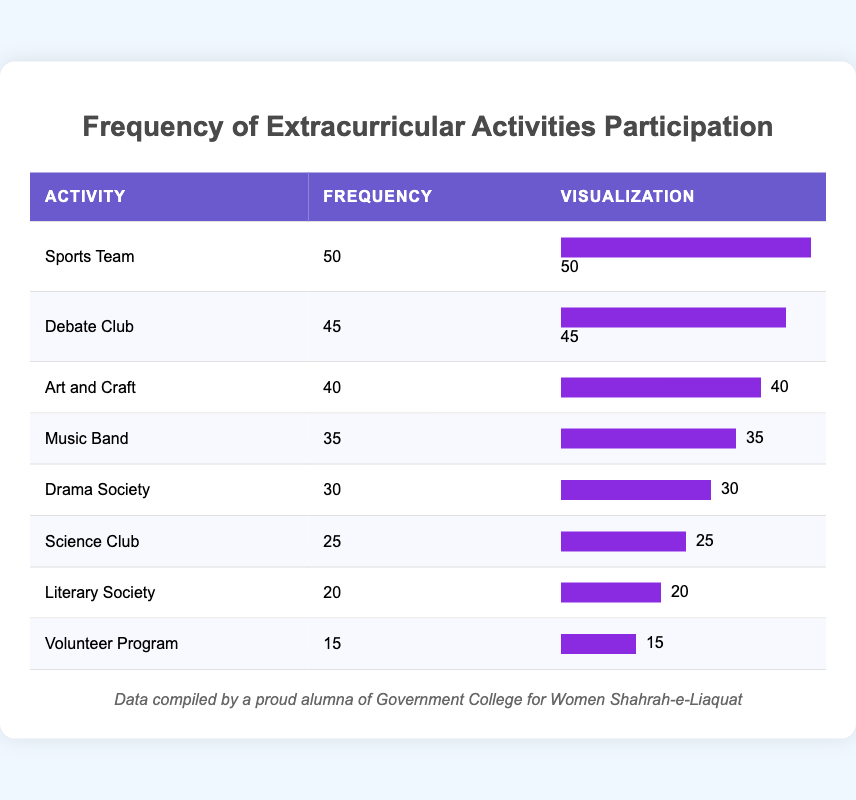What is the frequency count for the Sports Team activity? The table shows the frequency count for each extracurricular activity. For the Sports Team, the frequency listed is 50.
Answer: 50 Which activity has the highest participation? By examining the frequency counts listed in the table, the Sports Team shows the highest participation with a frequency of 50.
Answer: Sports Team What is the total frequency of participation for Debate Club and Music Band combined? To find the total frequency for Debate Club and Music Band, we add their frequencies: Debate Club is 45 and Music Band is 35. Hence, 45 + 35 = 80.
Answer: 80 Is there a higher participation in Art and Craft compared to Science Club? The table lists the frequency as 40 for Art and Craft and 25 for Science Club. Since 40 is greater than 25, the participation in Art and Craft is indeed higher.
Answer: Yes What is the median frequency of extracurricular activities participation? To find the median, we first list the frequencies in ascending order: 15, 20, 25, 30, 35, 40, 45, 50. As there are 8 values, the median is the average of the 4th and 5th values: (30 + 35) / 2 = 32.5.
Answer: 32.5 How many students participated in total across all activities? We sum the frequencies for all activities: 45 + 30 + 25 + 40 + 50 + 35 + 20 + 15 = 250.
Answer: 250 Is the frequency of the Volunteer Program less than 20? The frequency count for the Volunteer Program is 15, which is less than 20. Thus, the statement is true.
Answer: Yes Which activity has the lowest participation, and what is its frequency? Looking at the frequency counts, the Volunteer Program has the lowest participation at 15 students.
Answer: Volunteer Program, 15 